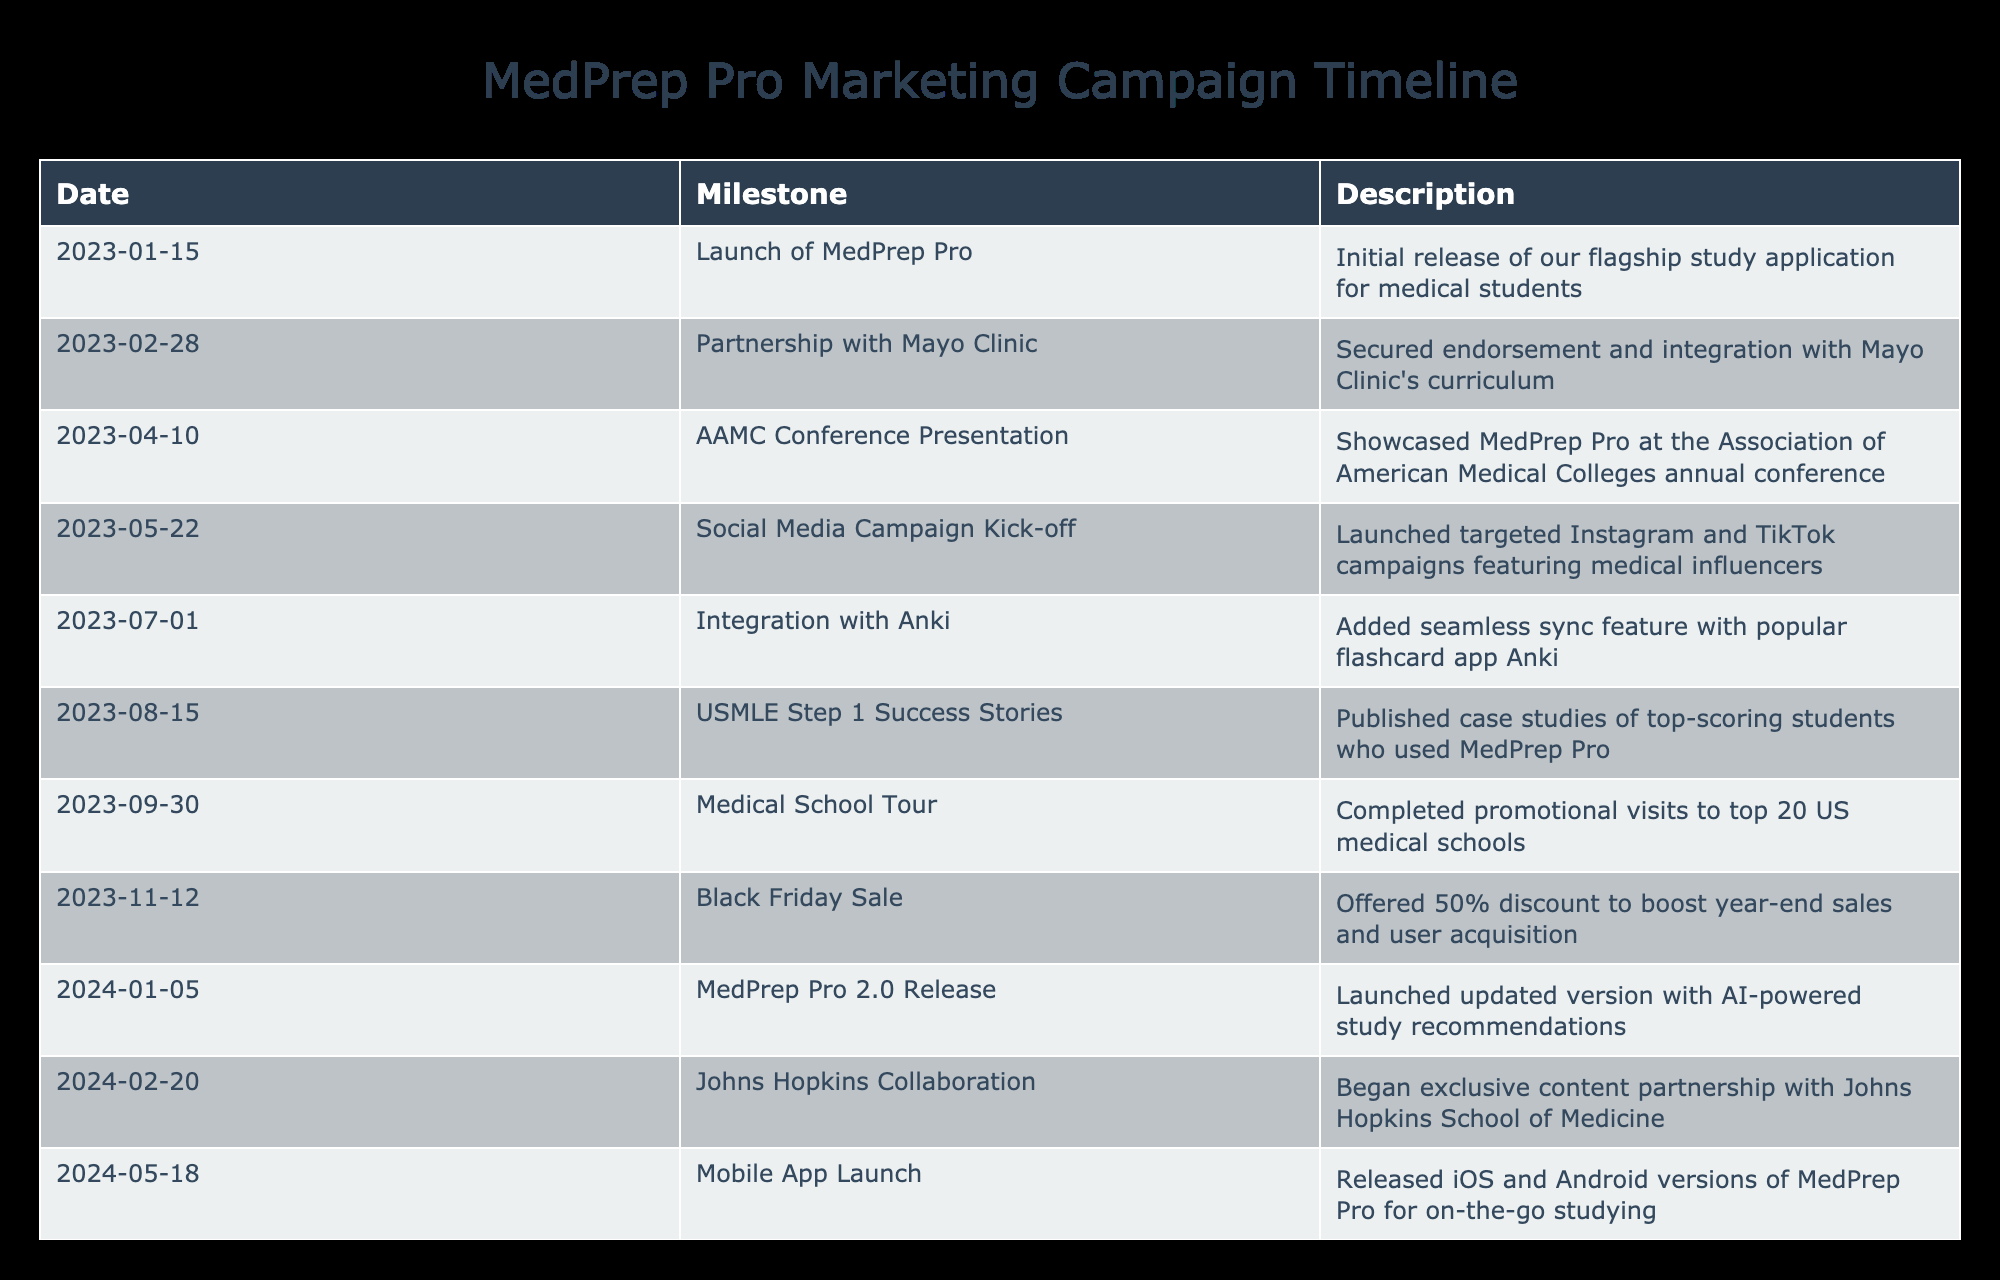What was the first milestone in the marketing campaign timeline? The first milestone listed in the table is "Launch of MedPrep Pro," which occurred on January 15, 2023.
Answer: Launch of MedPrep Pro How many partnerships were secured by the end of 2023? By the end of 2023, two partnerships were listed: one with Mayo Clinic and another collaboration with Johns Hopkins began in early 2024. Therefore, the count is two for 2023.
Answer: 1 What is the milestone that occurred closest to the AAMC Conference Presentation? The milestone that occurred immediately after the AAMC Conference Presentation on April 10, 2023, is the "Social Media Campaign Kick-off," which happened on May 22, 2023.
Answer: Social Media Campaign Kick-off What is the total number of milestones listed for 2024? There are seven milestones that occurred in 2024, including the MedPrep Pro 2.0 Release, Johns Hopkins Collaboration, Mobile App Launch, Residency Prep Module, MCAT Prep Integration, and Virtual Reality Anatomy Lab.
Answer: 6 Did the first half of 2024 include any noted collaborations? Yes, the first half of 2024 included the collaboration with Johns Hopkins School of Medicine that began on February 20, 2024.
Answer: Yes What was the unique feature added on July 1, 2023, and how does it contribute to the application? The unique feature added on July 1, 2023, was the integration with Anki, which allows users to seamlessly sync their flashcards, enhancing study organization and accessibility.
Answer: Integration with Anki Which milestone indicated an effort to target pre-med students, and when did it occur? The milestone targeting pre-med students was the addition of MCAT study materials, which occurred on September 10, 2024.
Answer: MCAT Prep Integration What percentage discount was offered during the Black Friday Sale? The Black Friday Sale offered a 50% discount on products to enhance year-end sales and user acquisition, providing significant savings to customers.
Answer: 50% 